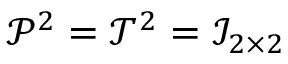<formula> <loc_0><loc_0><loc_500><loc_500>\mathcal { P } ^ { 2 } = \mathcal { T } ^ { 2 } = \mathcal { I } _ { 2 \times 2 }</formula> 